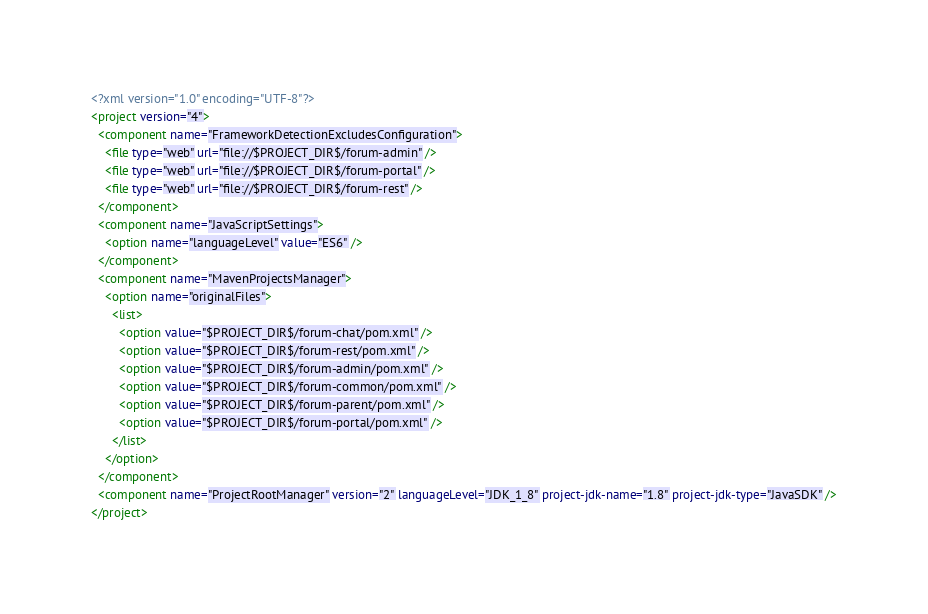<code> <loc_0><loc_0><loc_500><loc_500><_XML_><?xml version="1.0" encoding="UTF-8"?>
<project version="4">
  <component name="FrameworkDetectionExcludesConfiguration">
    <file type="web" url="file://$PROJECT_DIR$/forum-admin" />
    <file type="web" url="file://$PROJECT_DIR$/forum-portal" />
    <file type="web" url="file://$PROJECT_DIR$/forum-rest" />
  </component>
  <component name="JavaScriptSettings">
    <option name="languageLevel" value="ES6" />
  </component>
  <component name="MavenProjectsManager">
    <option name="originalFiles">
      <list>
        <option value="$PROJECT_DIR$/forum-chat/pom.xml" />
        <option value="$PROJECT_DIR$/forum-rest/pom.xml" />
        <option value="$PROJECT_DIR$/forum-admin/pom.xml" />
        <option value="$PROJECT_DIR$/forum-common/pom.xml" />
        <option value="$PROJECT_DIR$/forum-parent/pom.xml" />
        <option value="$PROJECT_DIR$/forum-portal/pom.xml" />
      </list>
    </option>
  </component>
  <component name="ProjectRootManager" version="2" languageLevel="JDK_1_8" project-jdk-name="1.8" project-jdk-type="JavaSDK" />
</project></code> 